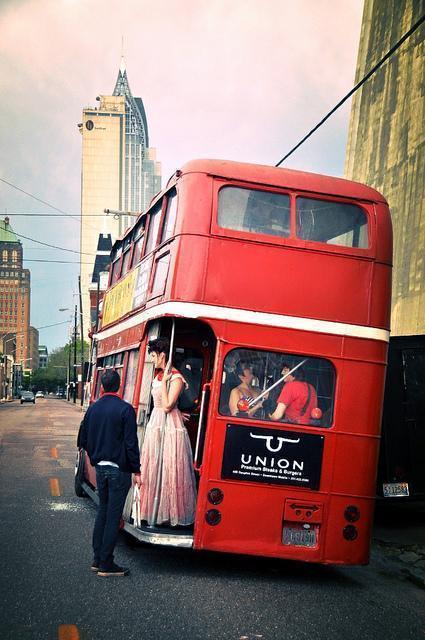What is the purpose of the wires above the vehicle?
Choose the right answer from the provided options to respond to the question.
Options: For climbing, for swinging, power source, for decoration. Power source. 